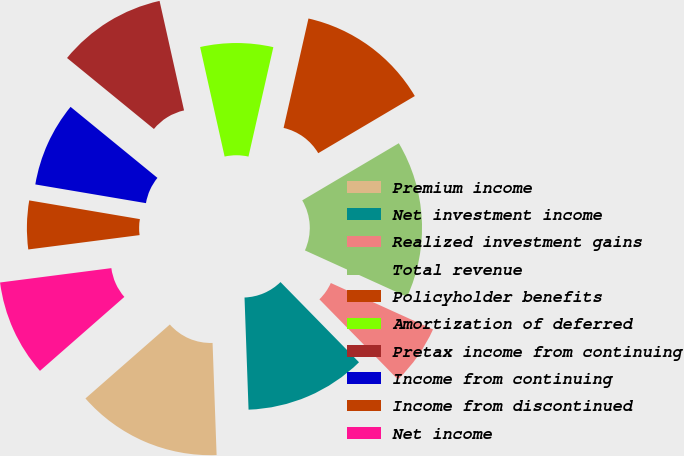Convert chart to OTSL. <chart><loc_0><loc_0><loc_500><loc_500><pie_chart><fcel>Premium income<fcel>Net investment income<fcel>Realized investment gains<fcel>Total revenue<fcel>Policyholder benefits<fcel>Amortization of deferred<fcel>Pretax income from continuing<fcel>Income from continuing<fcel>Income from discontinued<fcel>Net income<nl><fcel>14.12%<fcel>11.76%<fcel>5.88%<fcel>15.29%<fcel>12.94%<fcel>7.06%<fcel>10.59%<fcel>8.24%<fcel>4.71%<fcel>9.41%<nl></chart> 